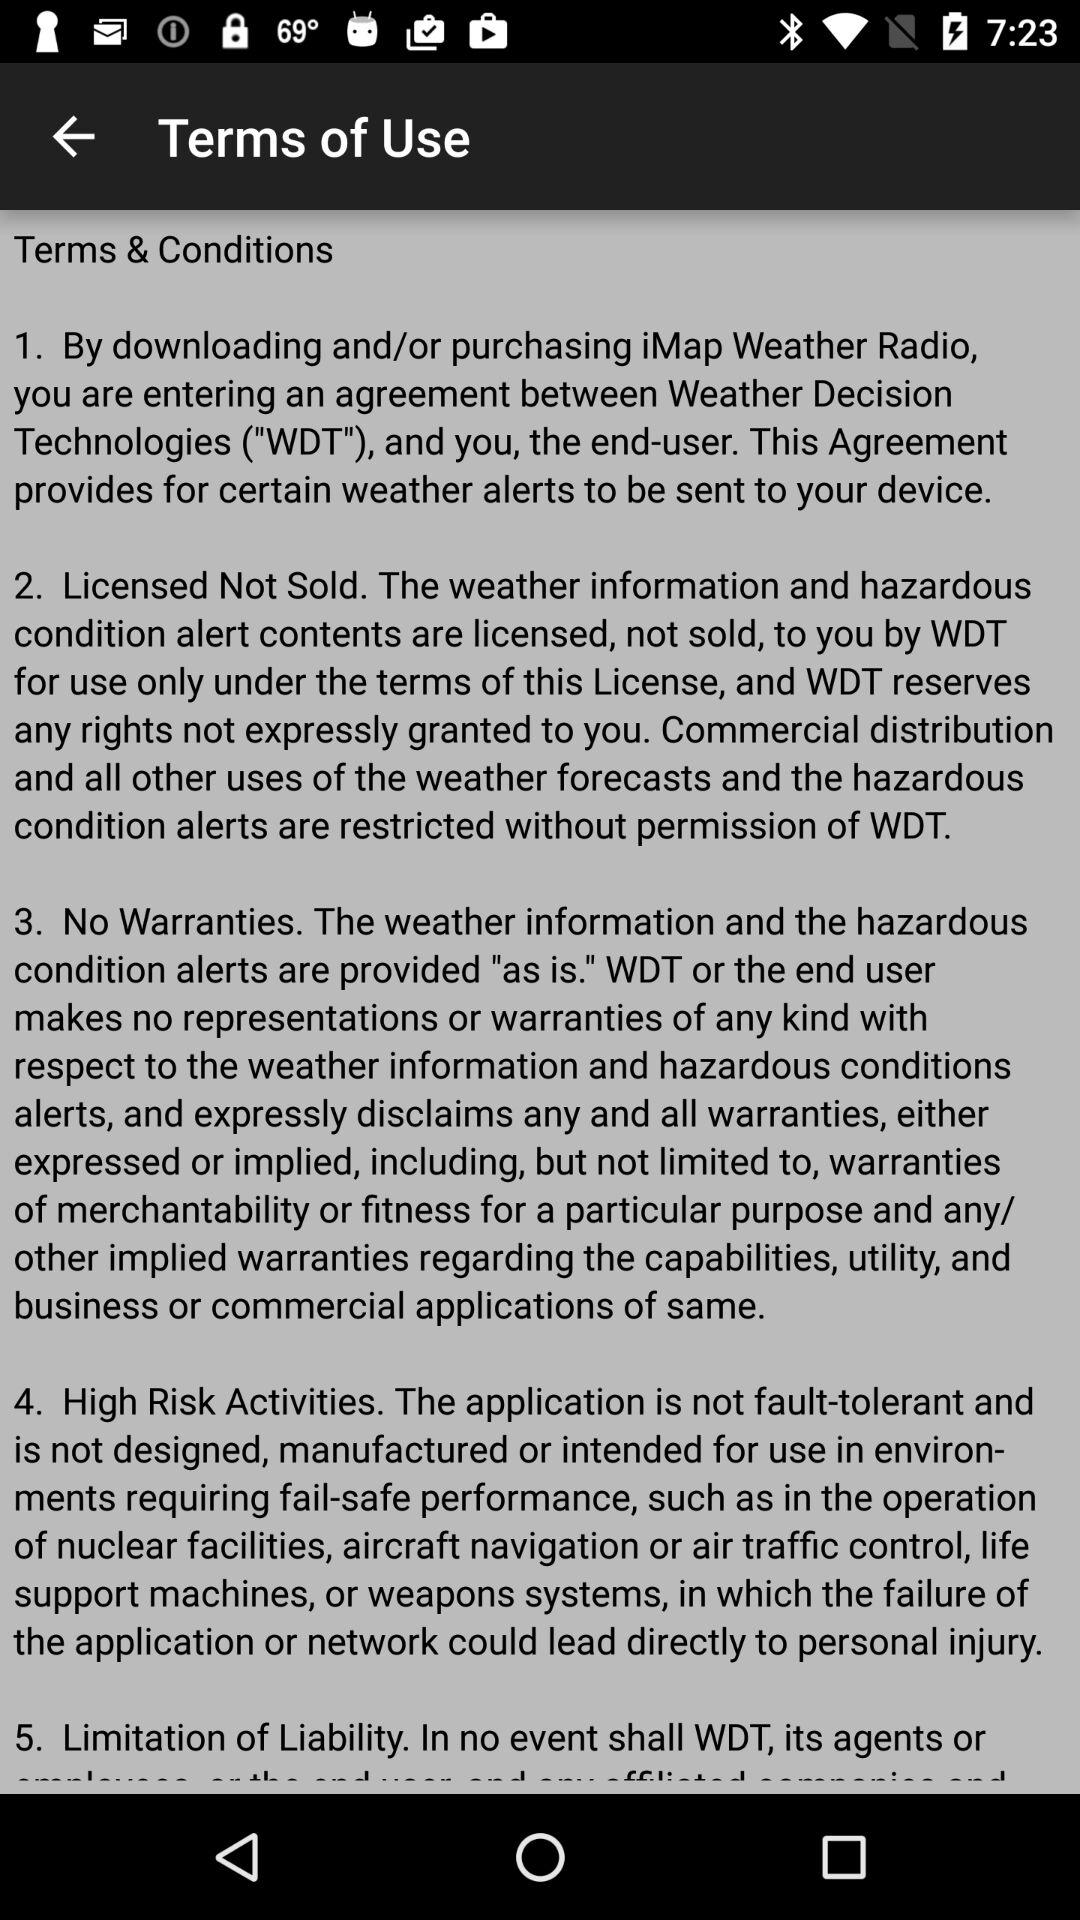How many sections are there in the terms and conditions?
Answer the question using a single word or phrase. 5 